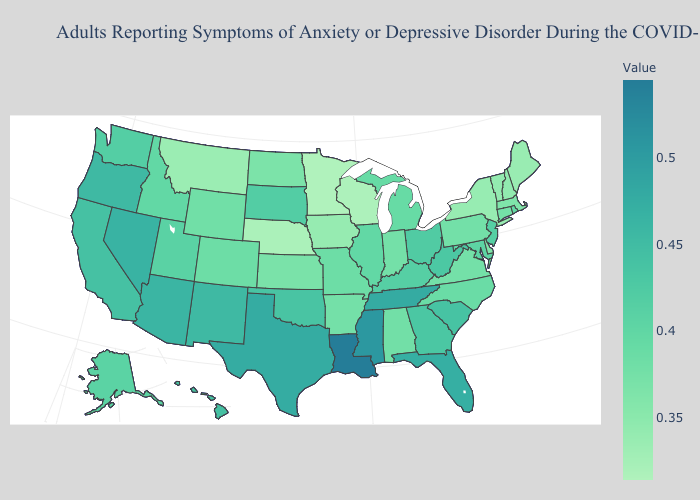Which states have the highest value in the USA?
Concise answer only. Louisiana. Does Nebraska have a higher value than South Dakota?
Write a very short answer. No. Does the map have missing data?
Keep it brief. No. Does New York have a higher value than Minnesota?
Answer briefly. Yes. 